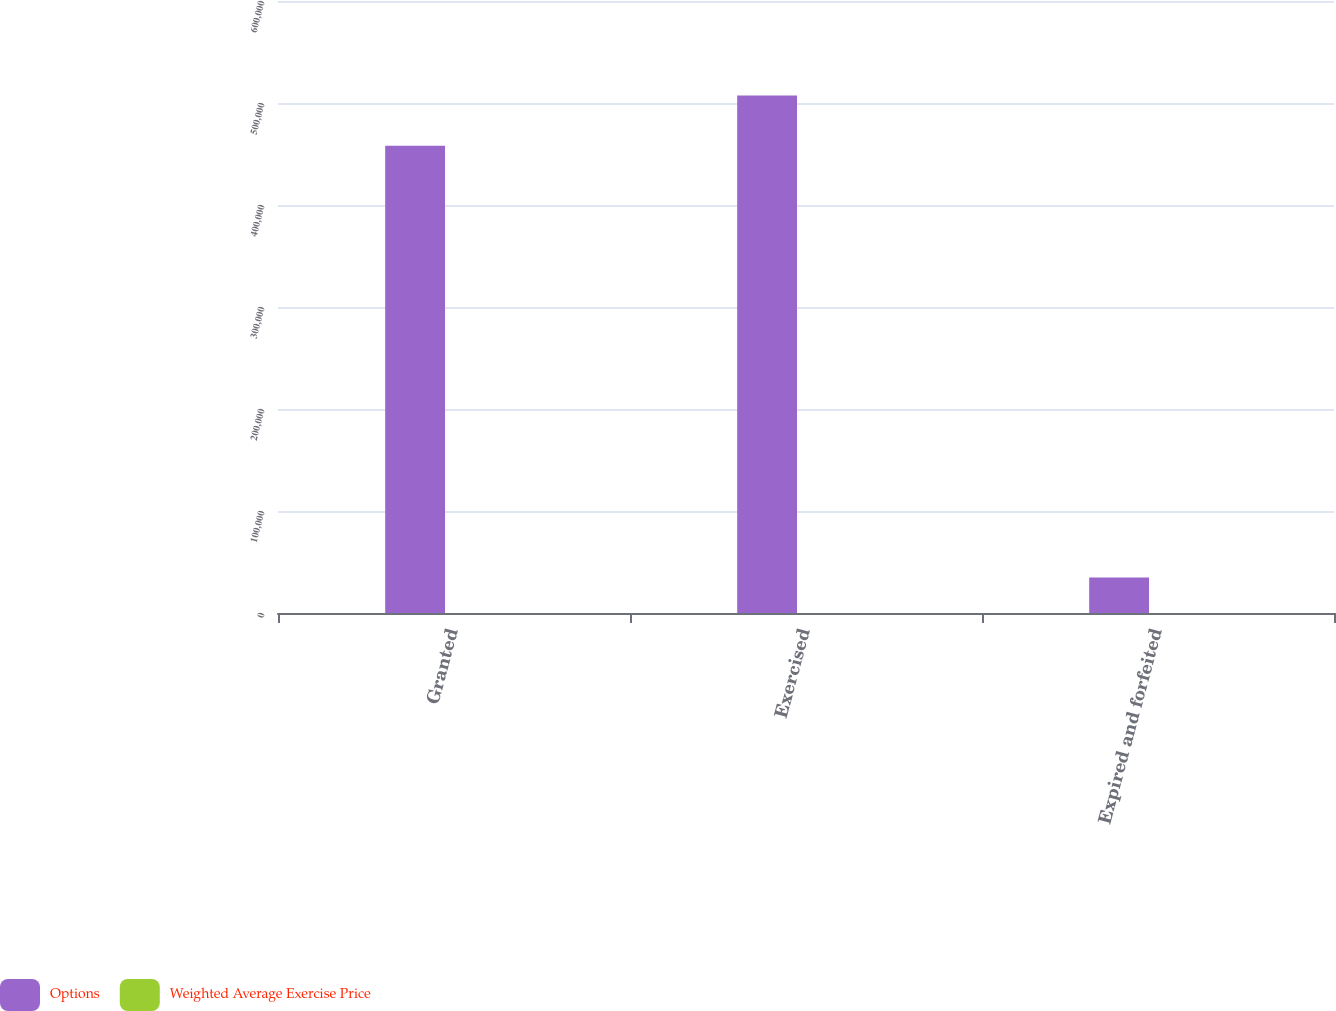Convert chart to OTSL. <chart><loc_0><loc_0><loc_500><loc_500><stacked_bar_chart><ecel><fcel>Granted<fcel>Exercised<fcel>Expired and forfeited<nl><fcel>Options<fcel>458008<fcel>507259<fcel>34749<nl><fcel>Weighted Average Exercise Price<fcel>62.42<fcel>42.29<fcel>50.5<nl></chart> 